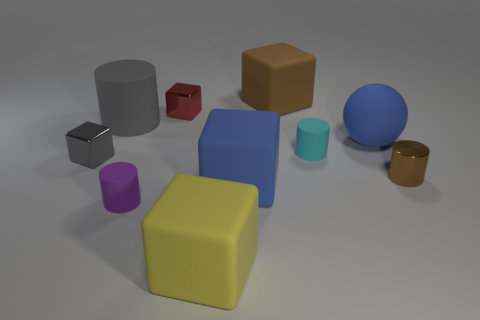How many other objects are the same material as the yellow cube?
Keep it short and to the point. 6. What number of shiny things are either tiny gray cubes or brown cubes?
Give a very brief answer. 1. What color is the tiny metal thing that is the same shape as the large gray thing?
Provide a succinct answer. Brown. What number of things are either brown things or blue rubber things?
Ensure brevity in your answer.  4. There is a large brown thing that is the same material as the yellow object; what is its shape?
Make the answer very short. Cube. How many big things are blue matte things or cyan metallic blocks?
Keep it short and to the point. 2. What number of other objects are the same color as the big rubber sphere?
Keep it short and to the point. 1. What number of matte cylinders are on the left side of the matte cylinder in front of the tiny block in front of the large rubber sphere?
Your answer should be very brief. 1. Is the size of the gray object that is behind the blue ball the same as the purple matte thing?
Your response must be concise. No. Are there fewer large gray objects that are in front of the tiny cyan cylinder than large blue matte cubes to the left of the tiny red metal thing?
Your answer should be compact. No. 